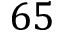<formula> <loc_0><loc_0><loc_500><loc_500>6 5</formula> 